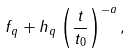Convert formula to latex. <formula><loc_0><loc_0><loc_500><loc_500>f _ { q } + h _ { q } \left ( \frac { t } { t _ { 0 } } \right ) ^ { - a } ,</formula> 